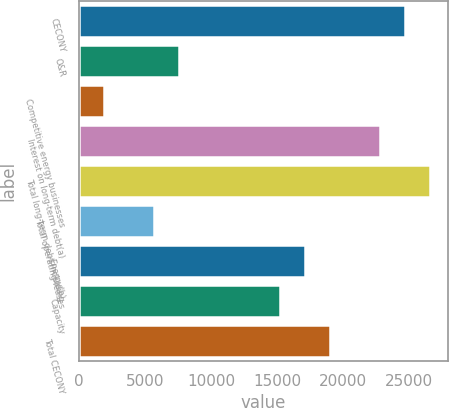Convert chart. <chart><loc_0><loc_0><loc_500><loc_500><bar_chart><fcel>CECONY<fcel>O&R<fcel>Competitive energy businesses<fcel>Interest on long-term debt(a)<fcel>Total long-term debt including<fcel>Total operating leases<fcel>Energy(b)<fcel>Capacity<fcel>Total CECONY<nl><fcel>24671.5<fcel>7594<fcel>1901.5<fcel>22774<fcel>26569<fcel>5696.5<fcel>17081.5<fcel>15184<fcel>18979<nl></chart> 